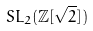<formula> <loc_0><loc_0><loc_500><loc_500>S L _ { 2 } ( \mathbb { Z } [ { \sqrt { 2 } } ] )</formula> 